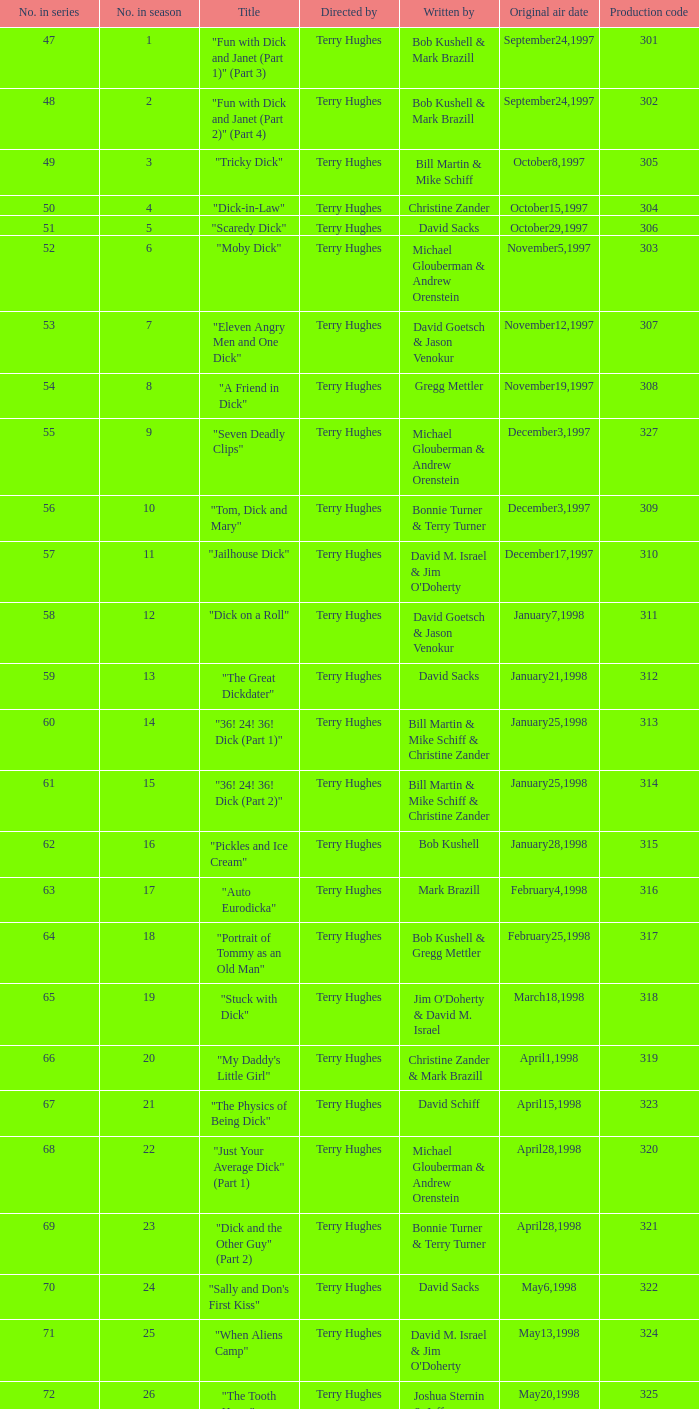What do they call episode 10 in the series? "Tom, Dick and Mary". 